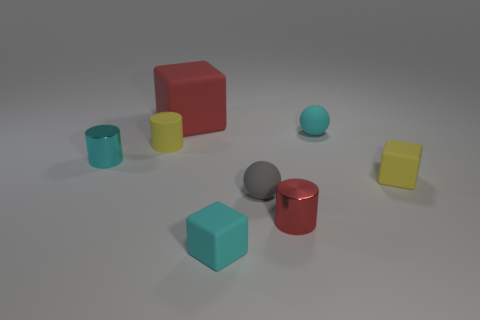What number of objects are big things left of the gray rubber ball or purple metal balls?
Give a very brief answer. 1. What is the size of the cyan cylinder?
Your answer should be very brief. Small. What material is the red thing behind the tiny gray rubber ball on the right side of the big rubber block?
Provide a short and direct response. Rubber. Is the size of the red object to the right of the cyan rubber block the same as the yellow matte cylinder?
Make the answer very short. Yes. Are there any small cylinders of the same color as the big matte object?
Offer a terse response. Yes. How many things are either cubes to the right of the red cube or tiny things that are to the left of the yellow cube?
Offer a very short reply. 7. Do the rubber cylinder and the large object have the same color?
Your response must be concise. No. What material is the thing that is the same color as the matte cylinder?
Ensure brevity in your answer.  Rubber. Is the number of small metallic objects that are behind the gray matte ball less than the number of small objects that are behind the yellow matte cube?
Make the answer very short. Yes. Does the tiny gray sphere have the same material as the red cylinder?
Provide a succinct answer. No. 